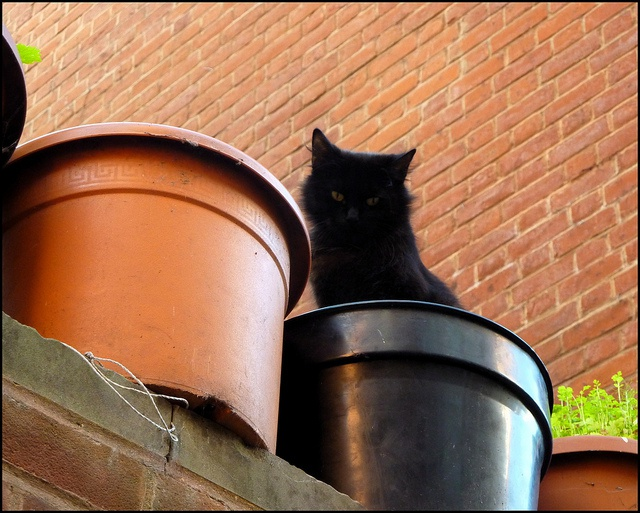Describe the objects in this image and their specific colors. I can see potted plant in black, gray, lightblue, and maroon tones, cat in black and gray tones, potted plant in black, brown, lime, and maroon tones, and potted plant in black, tan, brown, and gray tones in this image. 